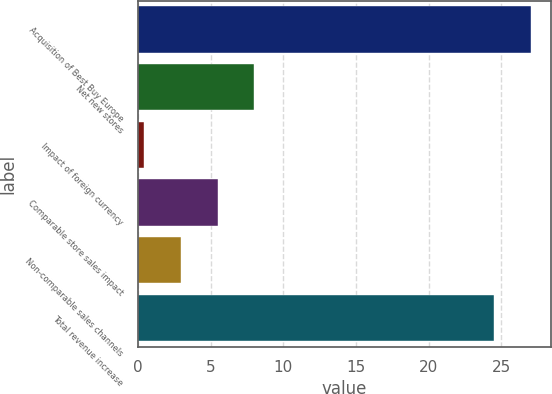<chart> <loc_0><loc_0><loc_500><loc_500><bar_chart><fcel>Acquisition of Best Buy Europe<fcel>Net new stores<fcel>Impact of foreign currency<fcel>Comparable store sales impact<fcel>Non-comparable sales channels<fcel>Total revenue increase<nl><fcel>27.04<fcel>8.02<fcel>0.4<fcel>5.48<fcel>2.94<fcel>24.5<nl></chart> 